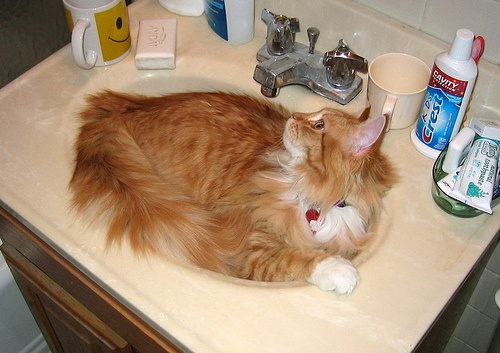Describe the objects in this image and their specific colors. I can see sink in black, tan, and beige tones, cat in black, brown, maroon, and tan tones, sink in black and tan tones, cup in black and tan tones, and cup in black, darkgray, olive, and tan tones in this image. 